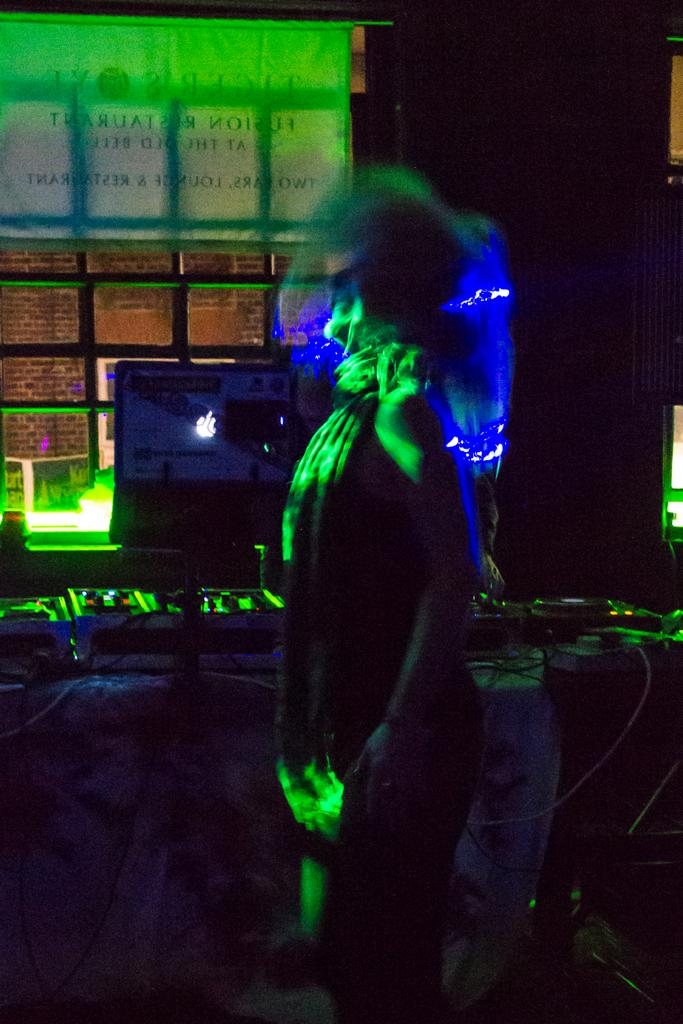What is the overall lighting condition in the image? The image is dark. Can you describe the person in the image? There is a person standing in the image. What is the background element in the image? There is a wall in the image. How many times does the person in the image kiss the wall? There is no indication in the image that the person is kissing the wall, so it cannot be determined from the picture. 